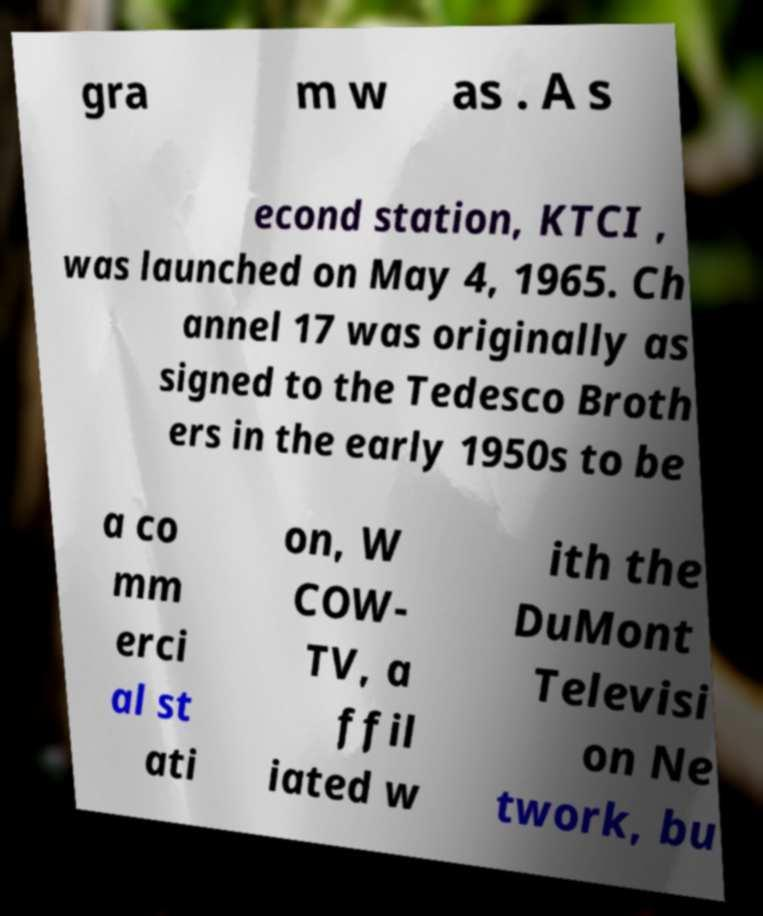There's text embedded in this image that I need extracted. Can you transcribe it verbatim? gra m w as . A s econd station, KTCI , was launched on May 4, 1965. Ch annel 17 was originally as signed to the Tedesco Broth ers in the early 1950s to be a co mm erci al st ati on, W COW- TV, a ffil iated w ith the DuMont Televisi on Ne twork, bu 